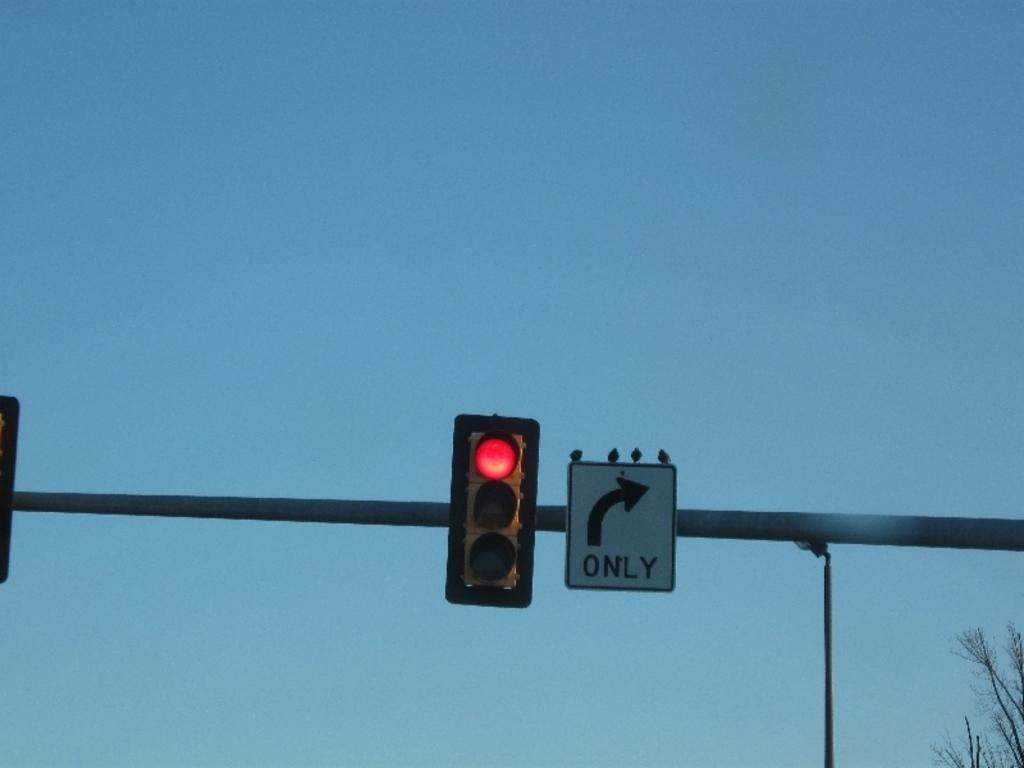Provide a one-sentence caption for the provided image. a red light and a sign indicating right turns only. 